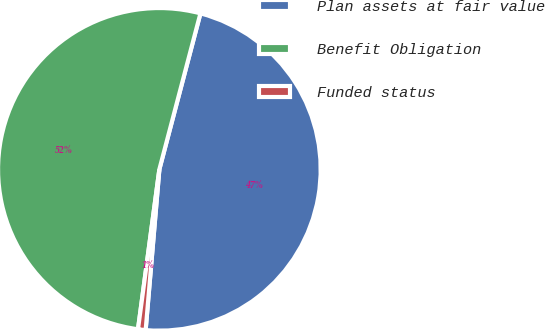<chart> <loc_0><loc_0><loc_500><loc_500><pie_chart><fcel>Plan assets at fair value<fcel>Benefit Obligation<fcel>Funded status<nl><fcel>47.26%<fcel>51.99%<fcel>0.76%<nl></chart> 